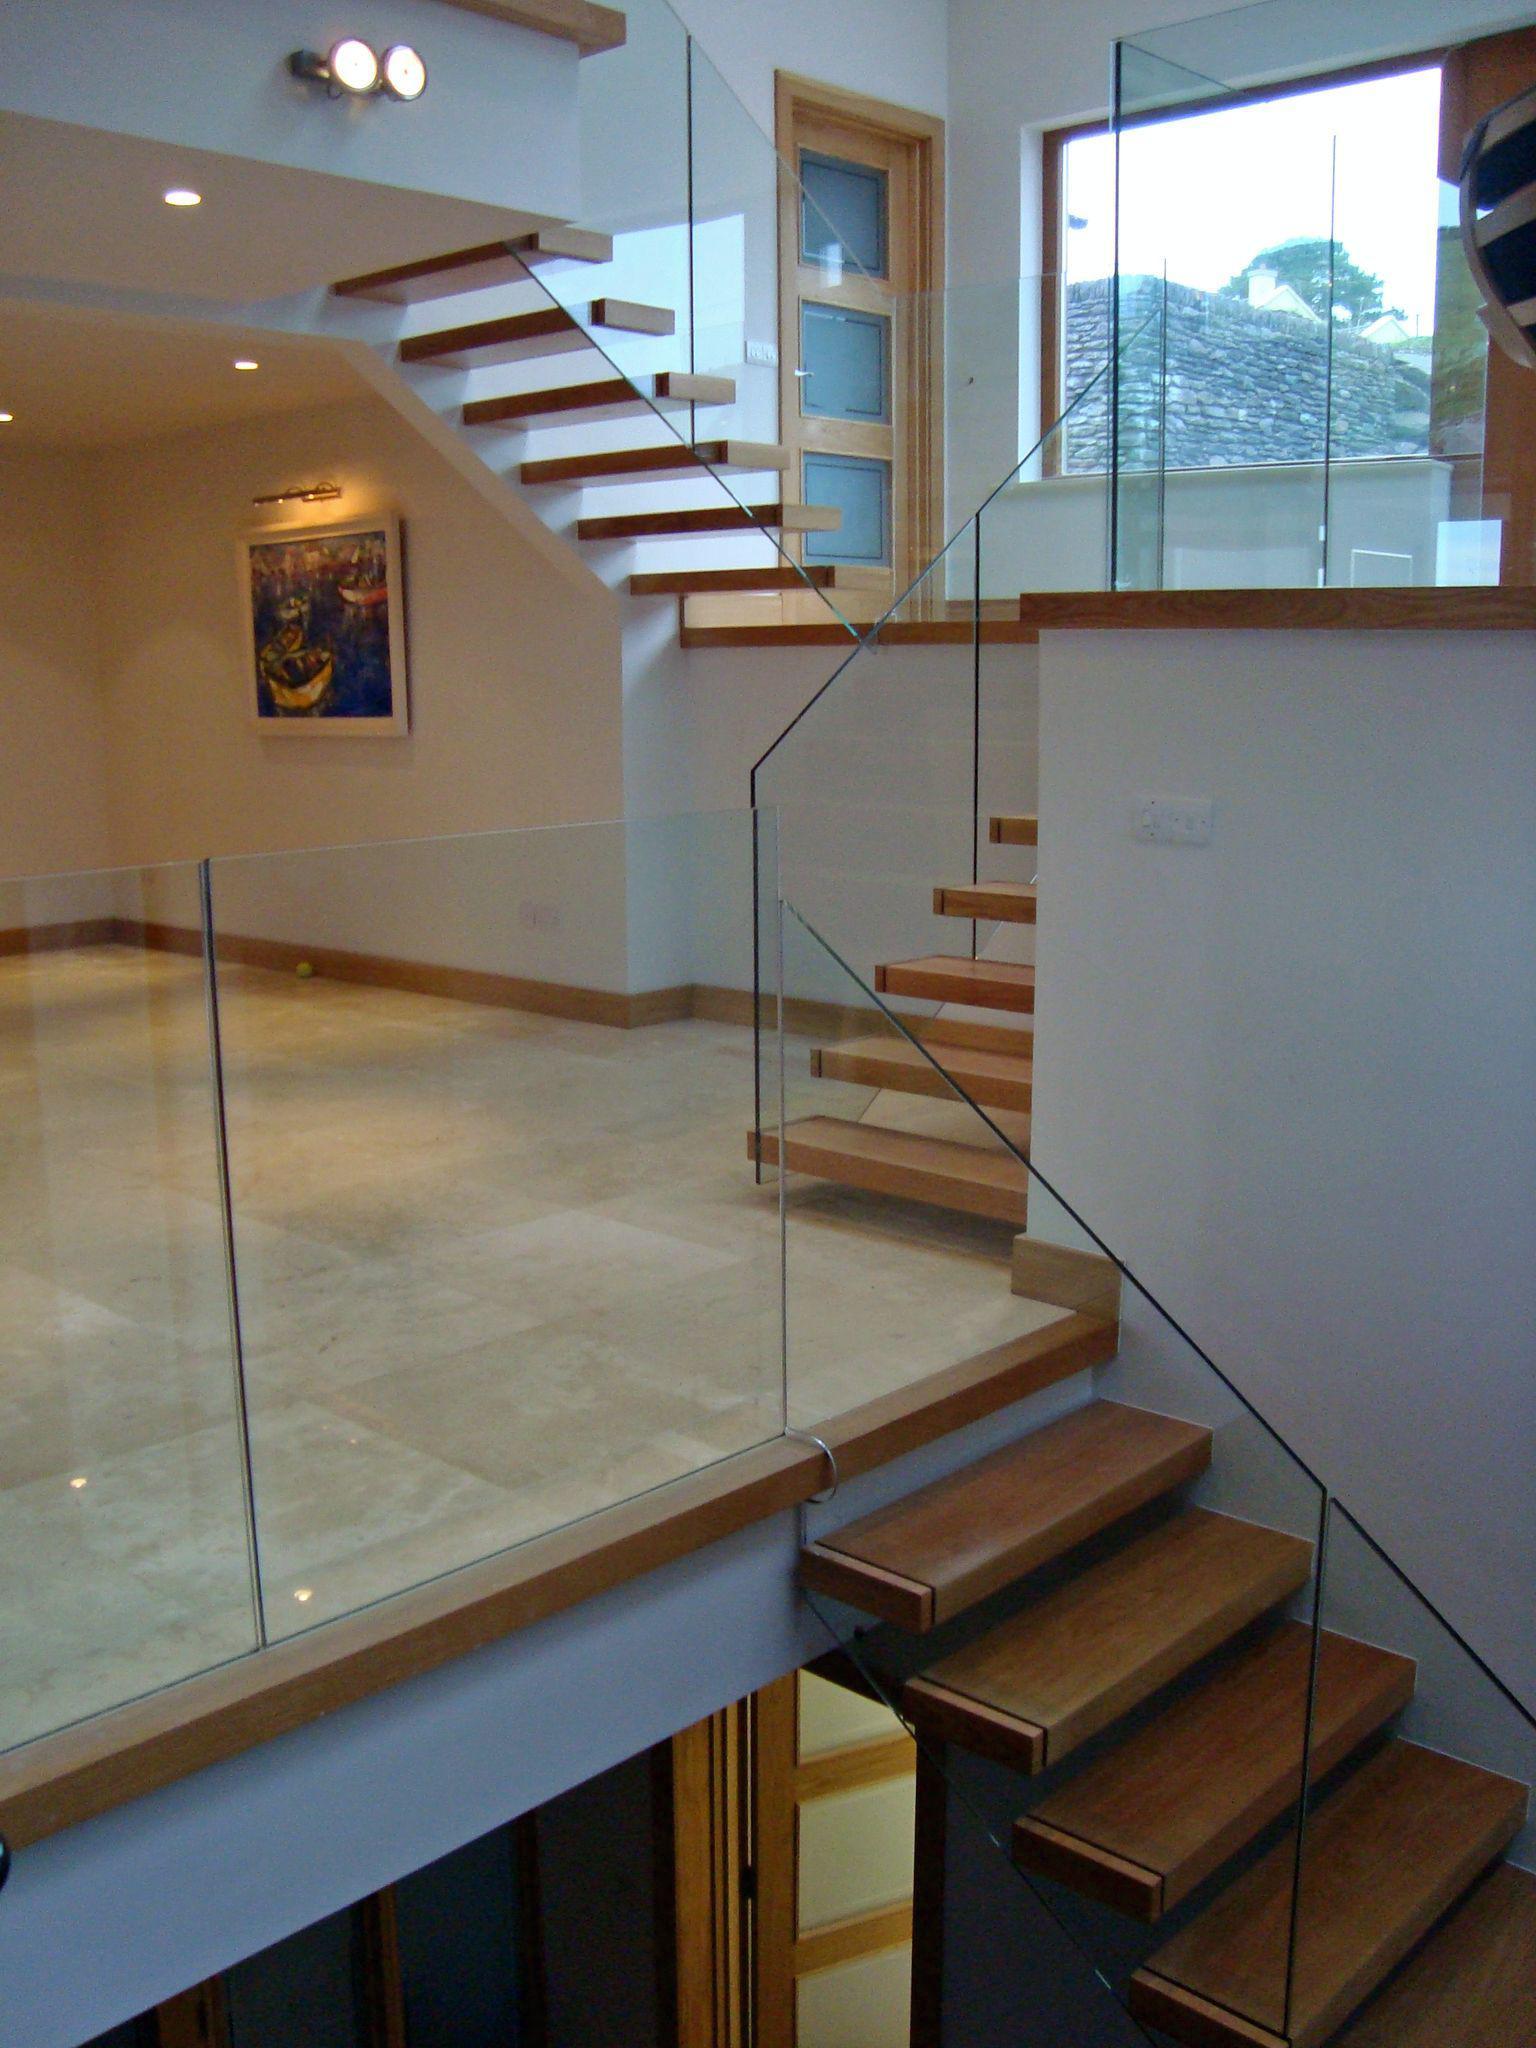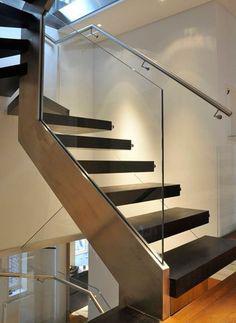The first image is the image on the left, the second image is the image on the right. For the images displayed, is the sentence "Each image features a glass-paneled balcony alongside a deck with plank boards, overlooking similar scenery." factually correct? Answer yes or no. No. The first image is the image on the left, the second image is the image on the right. For the images displayed, is the sentence "Both images are outside." factually correct? Answer yes or no. No. 